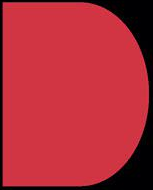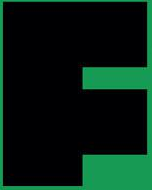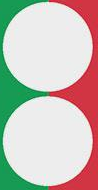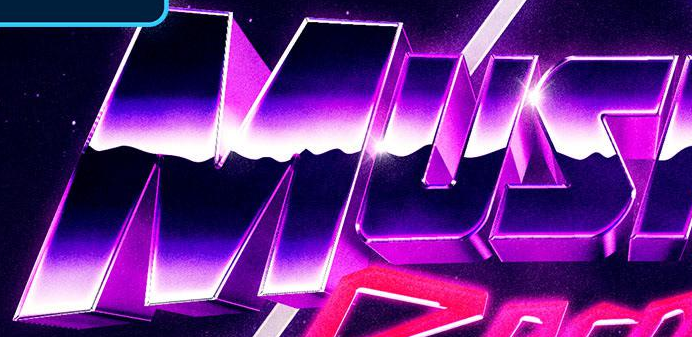Read the text from these images in sequence, separated by a semicolon. D; F; :; MUS 